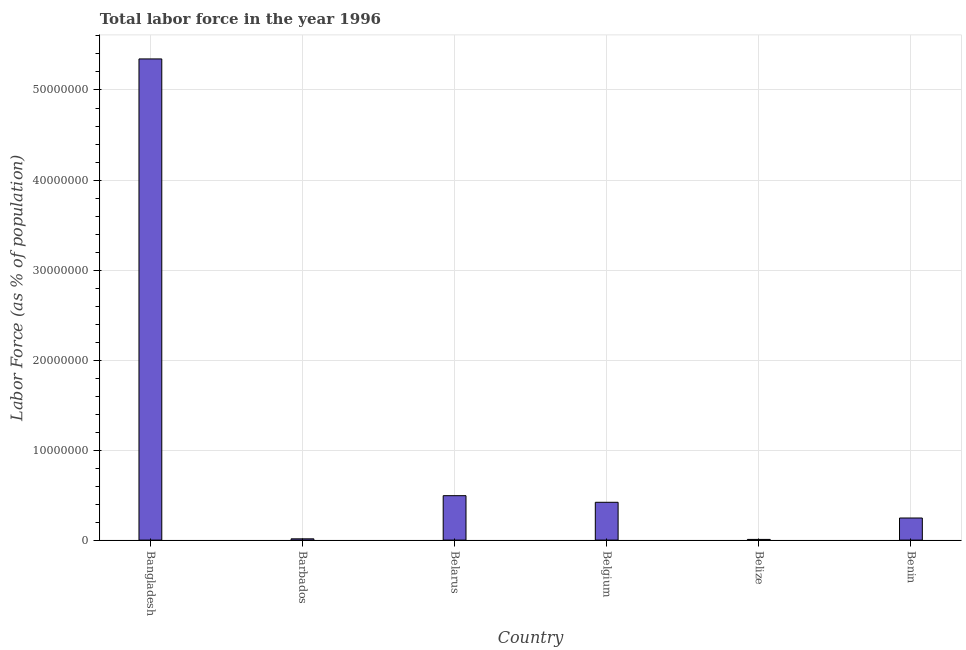What is the title of the graph?
Your answer should be compact. Total labor force in the year 1996. What is the label or title of the Y-axis?
Provide a short and direct response. Labor Force (as % of population). What is the total labor force in Belize?
Provide a short and direct response. 7.56e+04. Across all countries, what is the maximum total labor force?
Your answer should be very brief. 5.35e+07. Across all countries, what is the minimum total labor force?
Give a very brief answer. 7.56e+04. In which country was the total labor force maximum?
Offer a very short reply. Bangladesh. In which country was the total labor force minimum?
Offer a very short reply. Belize. What is the sum of the total labor force?
Make the answer very short. 6.53e+07. What is the difference between the total labor force in Belize and Benin?
Your answer should be compact. -2.38e+06. What is the average total labor force per country?
Your answer should be compact. 1.09e+07. What is the median total labor force?
Your response must be concise. 3.33e+06. What is the ratio of the total labor force in Belarus to that in Benin?
Give a very brief answer. 2.01. Is the total labor force in Barbados less than that in Belarus?
Keep it short and to the point. Yes. What is the difference between the highest and the second highest total labor force?
Give a very brief answer. 4.85e+07. What is the difference between the highest and the lowest total labor force?
Provide a short and direct response. 5.34e+07. Are the values on the major ticks of Y-axis written in scientific E-notation?
Give a very brief answer. No. What is the Labor Force (as % of population) in Bangladesh?
Your response must be concise. 5.35e+07. What is the Labor Force (as % of population) in Barbados?
Provide a short and direct response. 1.41e+05. What is the Labor Force (as % of population) of Belarus?
Keep it short and to the point. 4.93e+06. What is the Labor Force (as % of population) of Belgium?
Provide a succinct answer. 4.20e+06. What is the Labor Force (as % of population) of Belize?
Make the answer very short. 7.56e+04. What is the Labor Force (as % of population) of Benin?
Keep it short and to the point. 2.45e+06. What is the difference between the Labor Force (as % of population) in Bangladesh and Barbados?
Give a very brief answer. 5.33e+07. What is the difference between the Labor Force (as % of population) in Bangladesh and Belarus?
Your answer should be compact. 4.85e+07. What is the difference between the Labor Force (as % of population) in Bangladesh and Belgium?
Offer a very short reply. 4.92e+07. What is the difference between the Labor Force (as % of population) in Bangladesh and Belize?
Offer a terse response. 5.34e+07. What is the difference between the Labor Force (as % of population) in Bangladesh and Benin?
Your response must be concise. 5.10e+07. What is the difference between the Labor Force (as % of population) in Barbados and Belarus?
Make the answer very short. -4.79e+06. What is the difference between the Labor Force (as % of population) in Barbados and Belgium?
Keep it short and to the point. -4.06e+06. What is the difference between the Labor Force (as % of population) in Barbados and Belize?
Provide a succinct answer. 6.57e+04. What is the difference between the Labor Force (as % of population) in Barbados and Benin?
Your response must be concise. -2.31e+06. What is the difference between the Labor Force (as % of population) in Belarus and Belgium?
Your answer should be very brief. 7.33e+05. What is the difference between the Labor Force (as % of population) in Belarus and Belize?
Keep it short and to the point. 4.86e+06. What is the difference between the Labor Force (as % of population) in Belarus and Benin?
Keep it short and to the point. 2.48e+06. What is the difference between the Labor Force (as % of population) in Belgium and Belize?
Make the answer very short. 4.13e+06. What is the difference between the Labor Force (as % of population) in Belgium and Benin?
Your answer should be very brief. 1.75e+06. What is the difference between the Labor Force (as % of population) in Belize and Benin?
Offer a terse response. -2.38e+06. What is the ratio of the Labor Force (as % of population) in Bangladesh to that in Barbados?
Make the answer very short. 378.37. What is the ratio of the Labor Force (as % of population) in Bangladesh to that in Belarus?
Make the answer very short. 10.83. What is the ratio of the Labor Force (as % of population) in Bangladesh to that in Belgium?
Offer a terse response. 12.72. What is the ratio of the Labor Force (as % of population) in Bangladesh to that in Belize?
Ensure brevity in your answer.  707.27. What is the ratio of the Labor Force (as % of population) in Bangladesh to that in Benin?
Ensure brevity in your answer.  21.77. What is the ratio of the Labor Force (as % of population) in Barbados to that in Belarus?
Offer a very short reply. 0.03. What is the ratio of the Labor Force (as % of population) in Barbados to that in Belgium?
Keep it short and to the point. 0.03. What is the ratio of the Labor Force (as % of population) in Barbados to that in Belize?
Your answer should be compact. 1.87. What is the ratio of the Labor Force (as % of population) in Barbados to that in Benin?
Make the answer very short. 0.06. What is the ratio of the Labor Force (as % of population) in Belarus to that in Belgium?
Offer a terse response. 1.18. What is the ratio of the Labor Force (as % of population) in Belarus to that in Belize?
Give a very brief answer. 65.29. What is the ratio of the Labor Force (as % of population) in Belarus to that in Benin?
Give a very brief answer. 2.01. What is the ratio of the Labor Force (as % of population) in Belgium to that in Belize?
Give a very brief answer. 55.59. What is the ratio of the Labor Force (as % of population) in Belgium to that in Benin?
Offer a terse response. 1.71. What is the ratio of the Labor Force (as % of population) in Belize to that in Benin?
Your answer should be compact. 0.03. 